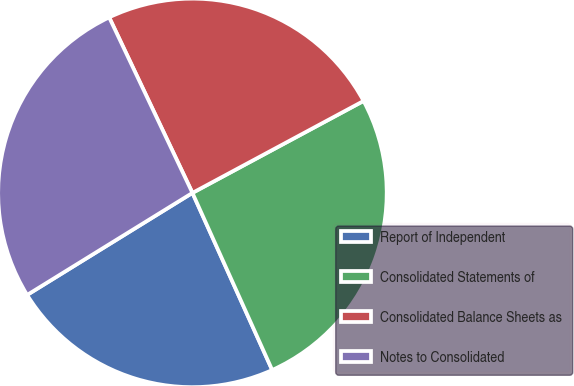<chart> <loc_0><loc_0><loc_500><loc_500><pie_chart><fcel>Report of Independent<fcel>Consolidated Statements of<fcel>Consolidated Balance Sheets as<fcel>Notes to Consolidated<nl><fcel>22.93%<fcel>26.11%<fcel>24.2%<fcel>26.75%<nl></chart> 